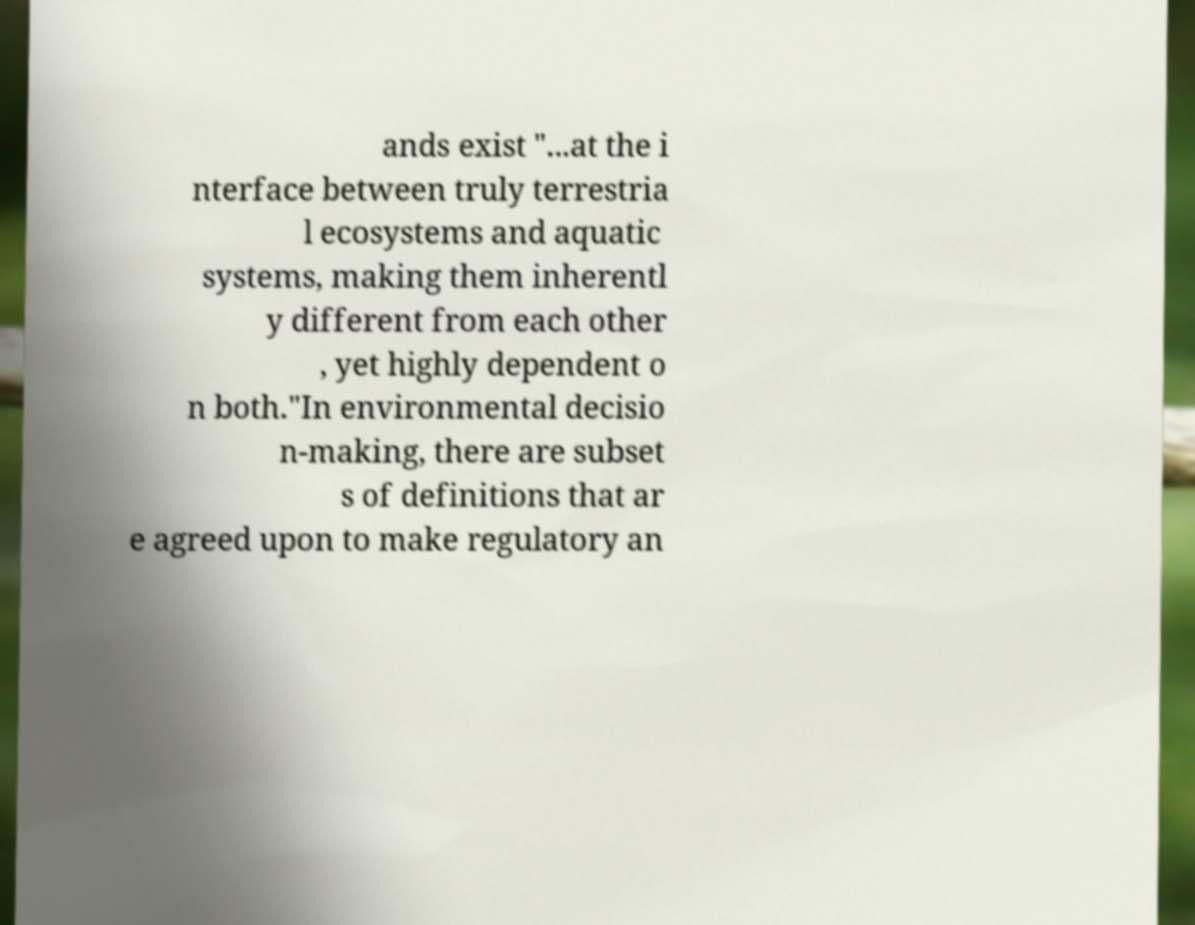For documentation purposes, I need the text within this image transcribed. Could you provide that? ands exist "...at the i nterface between truly terrestria l ecosystems and aquatic systems, making them inherentl y different from each other , yet highly dependent o n both."In environmental decisio n-making, there are subset s of definitions that ar e agreed upon to make regulatory an 